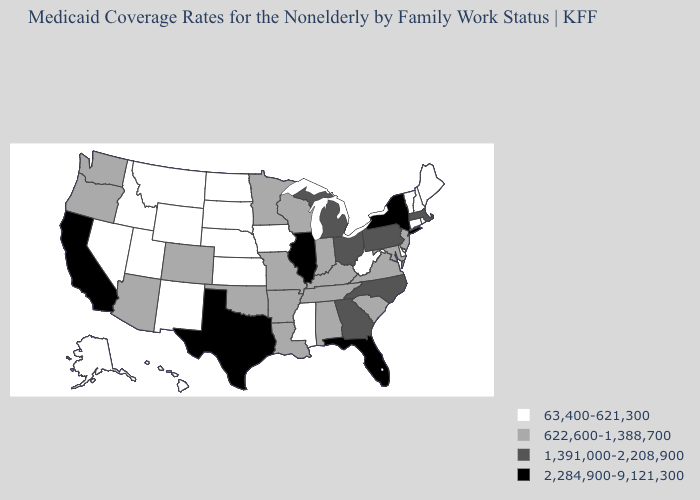Among the states that border Arkansas , which have the lowest value?
Answer briefly. Mississippi. Among the states that border Florida , does Alabama have the highest value?
Concise answer only. No. What is the value of Tennessee?
Answer briefly. 622,600-1,388,700. What is the highest value in states that border Washington?
Quick response, please. 622,600-1,388,700. What is the value of Massachusetts?
Short answer required. 1,391,000-2,208,900. What is the value of Iowa?
Be succinct. 63,400-621,300. What is the value of Virginia?
Answer briefly. 622,600-1,388,700. Name the states that have a value in the range 1,391,000-2,208,900?
Write a very short answer. Georgia, Massachusetts, Michigan, North Carolina, Ohio, Pennsylvania. How many symbols are there in the legend?
Write a very short answer. 4. What is the value of Maryland?
Be succinct. 622,600-1,388,700. Which states have the lowest value in the MidWest?
Concise answer only. Iowa, Kansas, Nebraska, North Dakota, South Dakota. Name the states that have a value in the range 63,400-621,300?
Quick response, please. Alaska, Connecticut, Delaware, Hawaii, Idaho, Iowa, Kansas, Maine, Mississippi, Montana, Nebraska, Nevada, New Hampshire, New Mexico, North Dakota, Rhode Island, South Dakota, Utah, Vermont, West Virginia, Wyoming. What is the highest value in states that border North Dakota?
Answer briefly. 622,600-1,388,700. Which states have the lowest value in the South?
Give a very brief answer. Delaware, Mississippi, West Virginia. Does the first symbol in the legend represent the smallest category?
Write a very short answer. Yes. 